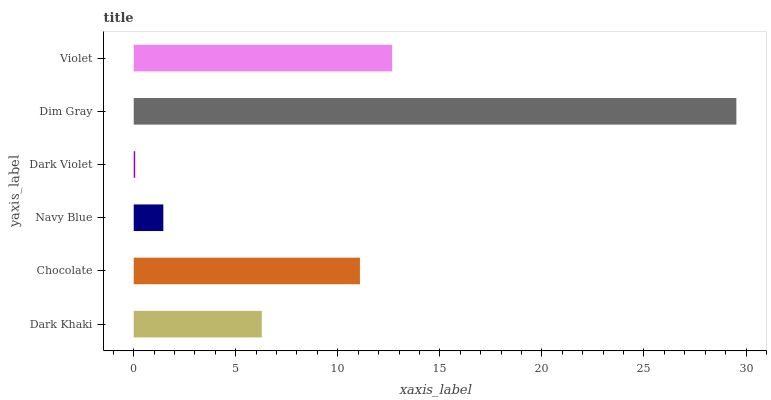Is Dark Violet the minimum?
Answer yes or no. Yes. Is Dim Gray the maximum?
Answer yes or no. Yes. Is Chocolate the minimum?
Answer yes or no. No. Is Chocolate the maximum?
Answer yes or no. No. Is Chocolate greater than Dark Khaki?
Answer yes or no. Yes. Is Dark Khaki less than Chocolate?
Answer yes or no. Yes. Is Dark Khaki greater than Chocolate?
Answer yes or no. No. Is Chocolate less than Dark Khaki?
Answer yes or no. No. Is Chocolate the high median?
Answer yes or no. Yes. Is Dark Khaki the low median?
Answer yes or no. Yes. Is Dark Khaki the high median?
Answer yes or no. No. Is Violet the low median?
Answer yes or no. No. 